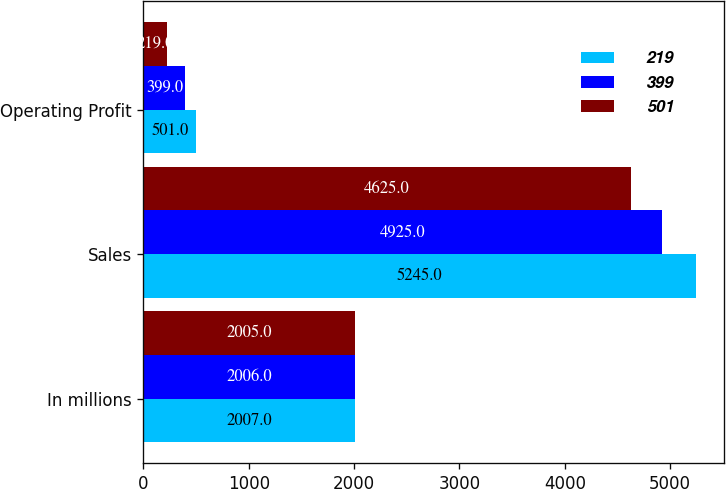Convert chart to OTSL. <chart><loc_0><loc_0><loc_500><loc_500><stacked_bar_chart><ecel><fcel>In millions<fcel>Sales<fcel>Operating Profit<nl><fcel>219<fcel>2007<fcel>5245<fcel>501<nl><fcel>399<fcel>2006<fcel>4925<fcel>399<nl><fcel>501<fcel>2005<fcel>4625<fcel>219<nl></chart> 